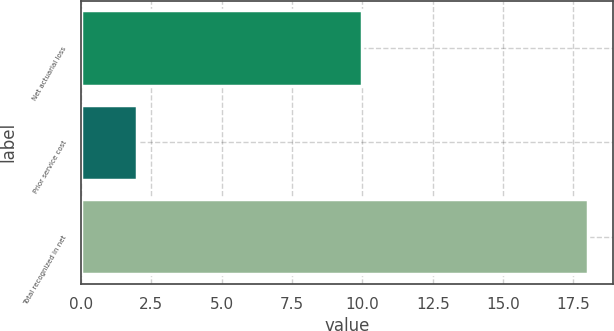Convert chart. <chart><loc_0><loc_0><loc_500><loc_500><bar_chart><fcel>Net actuarial loss<fcel>Prior service cost<fcel>Total recognized in net<nl><fcel>10<fcel>2<fcel>18<nl></chart> 